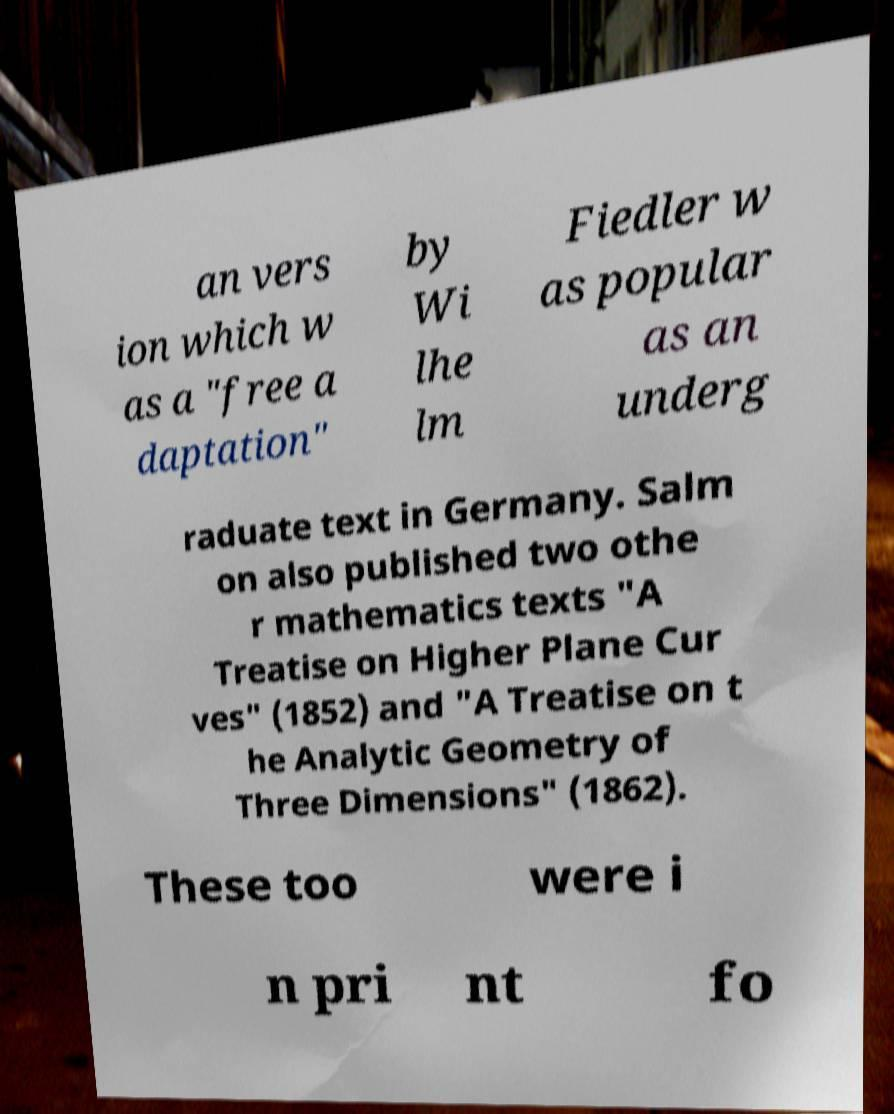What messages or text are displayed in this image? I need them in a readable, typed format. an vers ion which w as a "free a daptation" by Wi lhe lm Fiedler w as popular as an underg raduate text in Germany. Salm on also published two othe r mathematics texts "A Treatise on Higher Plane Cur ves" (1852) and "A Treatise on t he Analytic Geometry of Three Dimensions" (1862). These too were i n pri nt fo 